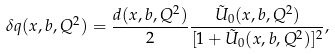<formula> <loc_0><loc_0><loc_500><loc_500>\delta q ( x , b , Q ^ { 2 } ) = \frac { d ( x , b , Q ^ { 2 } ) } { 2 } \frac { \tilde { U } _ { 0 } ( x , b , Q ^ { 2 } ) } { [ 1 + \tilde { U } _ { 0 } ( x , b , Q ^ { 2 } ) ] ^ { 2 } } ,</formula> 